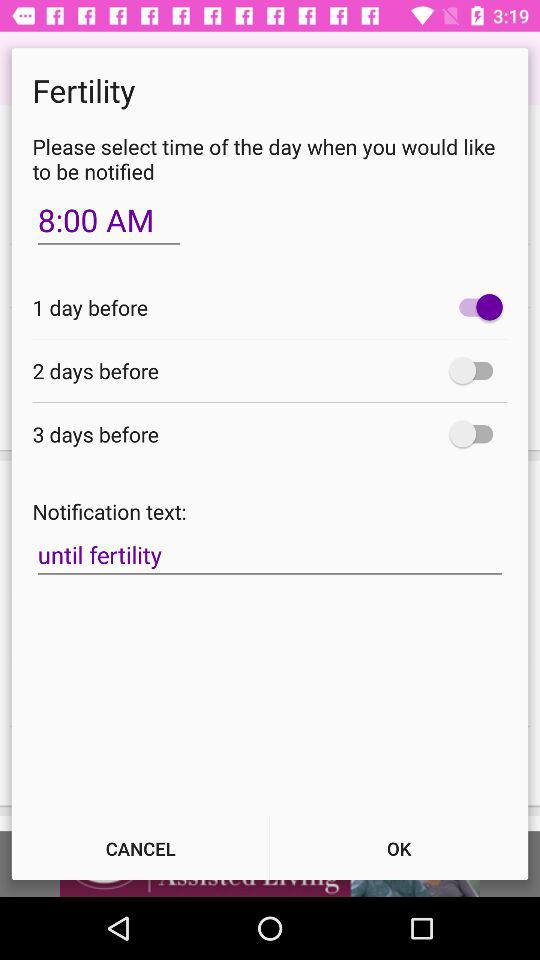What is the selected time for notification? The selected time for notification is 8:00 a.m. 